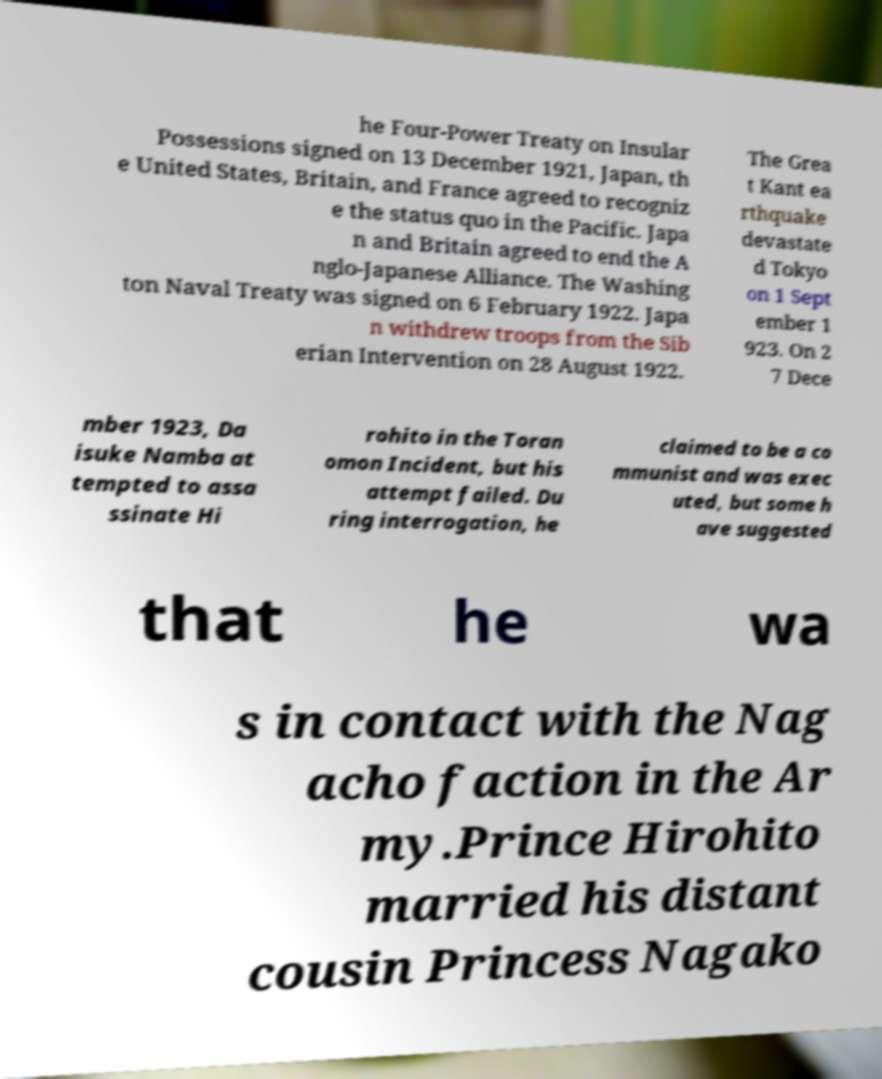There's text embedded in this image that I need extracted. Can you transcribe it verbatim? he Four-Power Treaty on Insular Possessions signed on 13 December 1921, Japan, th e United States, Britain, and France agreed to recogniz e the status quo in the Pacific. Japa n and Britain agreed to end the A nglo-Japanese Alliance. The Washing ton Naval Treaty was signed on 6 February 1922. Japa n withdrew troops from the Sib erian Intervention on 28 August 1922. The Grea t Kant ea rthquake devastate d Tokyo on 1 Sept ember 1 923. On 2 7 Dece mber 1923, Da isuke Namba at tempted to assa ssinate Hi rohito in the Toran omon Incident, but his attempt failed. Du ring interrogation, he claimed to be a co mmunist and was exec uted, but some h ave suggested that he wa s in contact with the Nag acho faction in the Ar my.Prince Hirohito married his distant cousin Princess Nagako 